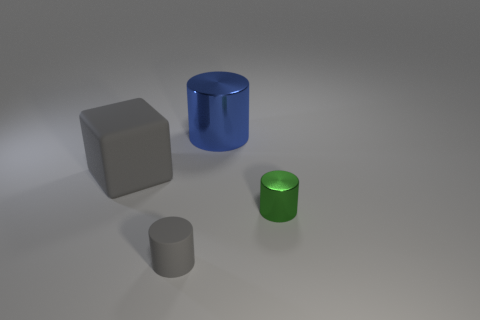Add 1 tiny gray matte cylinders. How many objects exist? 5 Subtract all cylinders. How many objects are left? 1 Subtract all large shiny objects. Subtract all large green matte spheres. How many objects are left? 3 Add 3 small gray things. How many small gray things are left? 4 Add 2 green objects. How many green objects exist? 3 Subtract 0 cyan balls. How many objects are left? 4 